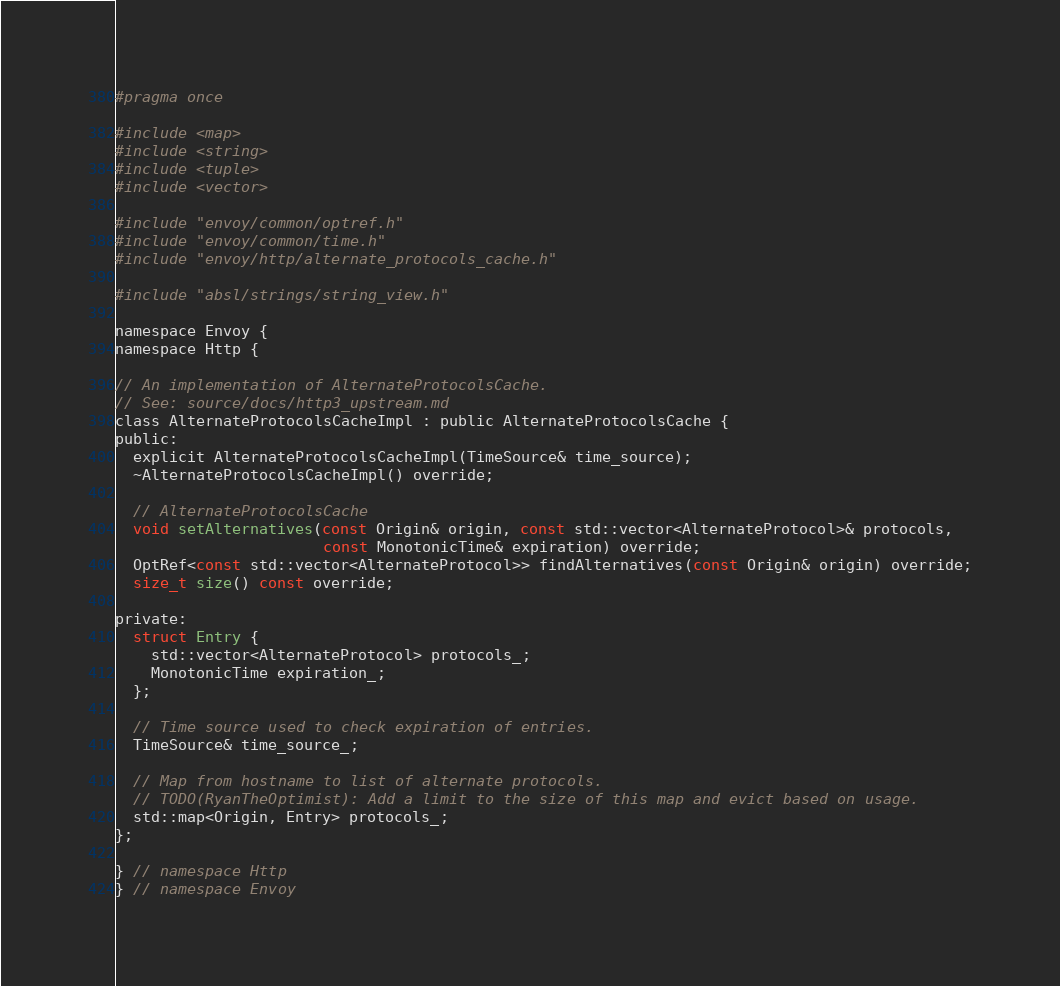<code> <loc_0><loc_0><loc_500><loc_500><_C_>#pragma once

#include <map>
#include <string>
#include <tuple>
#include <vector>

#include "envoy/common/optref.h"
#include "envoy/common/time.h"
#include "envoy/http/alternate_protocols_cache.h"

#include "absl/strings/string_view.h"

namespace Envoy {
namespace Http {

// An implementation of AlternateProtocolsCache.
// See: source/docs/http3_upstream.md
class AlternateProtocolsCacheImpl : public AlternateProtocolsCache {
public:
  explicit AlternateProtocolsCacheImpl(TimeSource& time_source);
  ~AlternateProtocolsCacheImpl() override;

  // AlternateProtocolsCache
  void setAlternatives(const Origin& origin, const std::vector<AlternateProtocol>& protocols,
                       const MonotonicTime& expiration) override;
  OptRef<const std::vector<AlternateProtocol>> findAlternatives(const Origin& origin) override;
  size_t size() const override;

private:
  struct Entry {
    std::vector<AlternateProtocol> protocols_;
    MonotonicTime expiration_;
  };

  // Time source used to check expiration of entries.
  TimeSource& time_source_;

  // Map from hostname to list of alternate protocols.
  // TODO(RyanTheOptimist): Add a limit to the size of this map and evict based on usage.
  std::map<Origin, Entry> protocols_;
};

} // namespace Http
} // namespace Envoy
</code> 